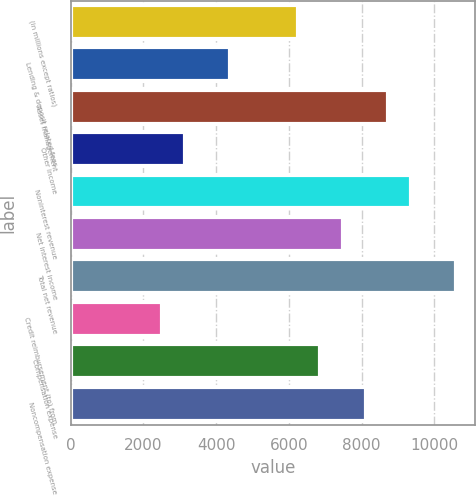<chart> <loc_0><loc_0><loc_500><loc_500><bar_chart><fcel>(in millions except ratios)<fcel>Lending & deposit related fees<fcel>Asset management<fcel>Other income<fcel>Noninterest revenue<fcel>Net interest income<fcel>Total net revenue<fcel>Credit reimbursement (to) from<fcel>Compensation expense<fcel>Noncompensation expense<nl><fcel>6241<fcel>4376.5<fcel>8727<fcel>3133.5<fcel>9348.5<fcel>7484<fcel>10591.5<fcel>2512<fcel>6862.5<fcel>8105.5<nl></chart> 